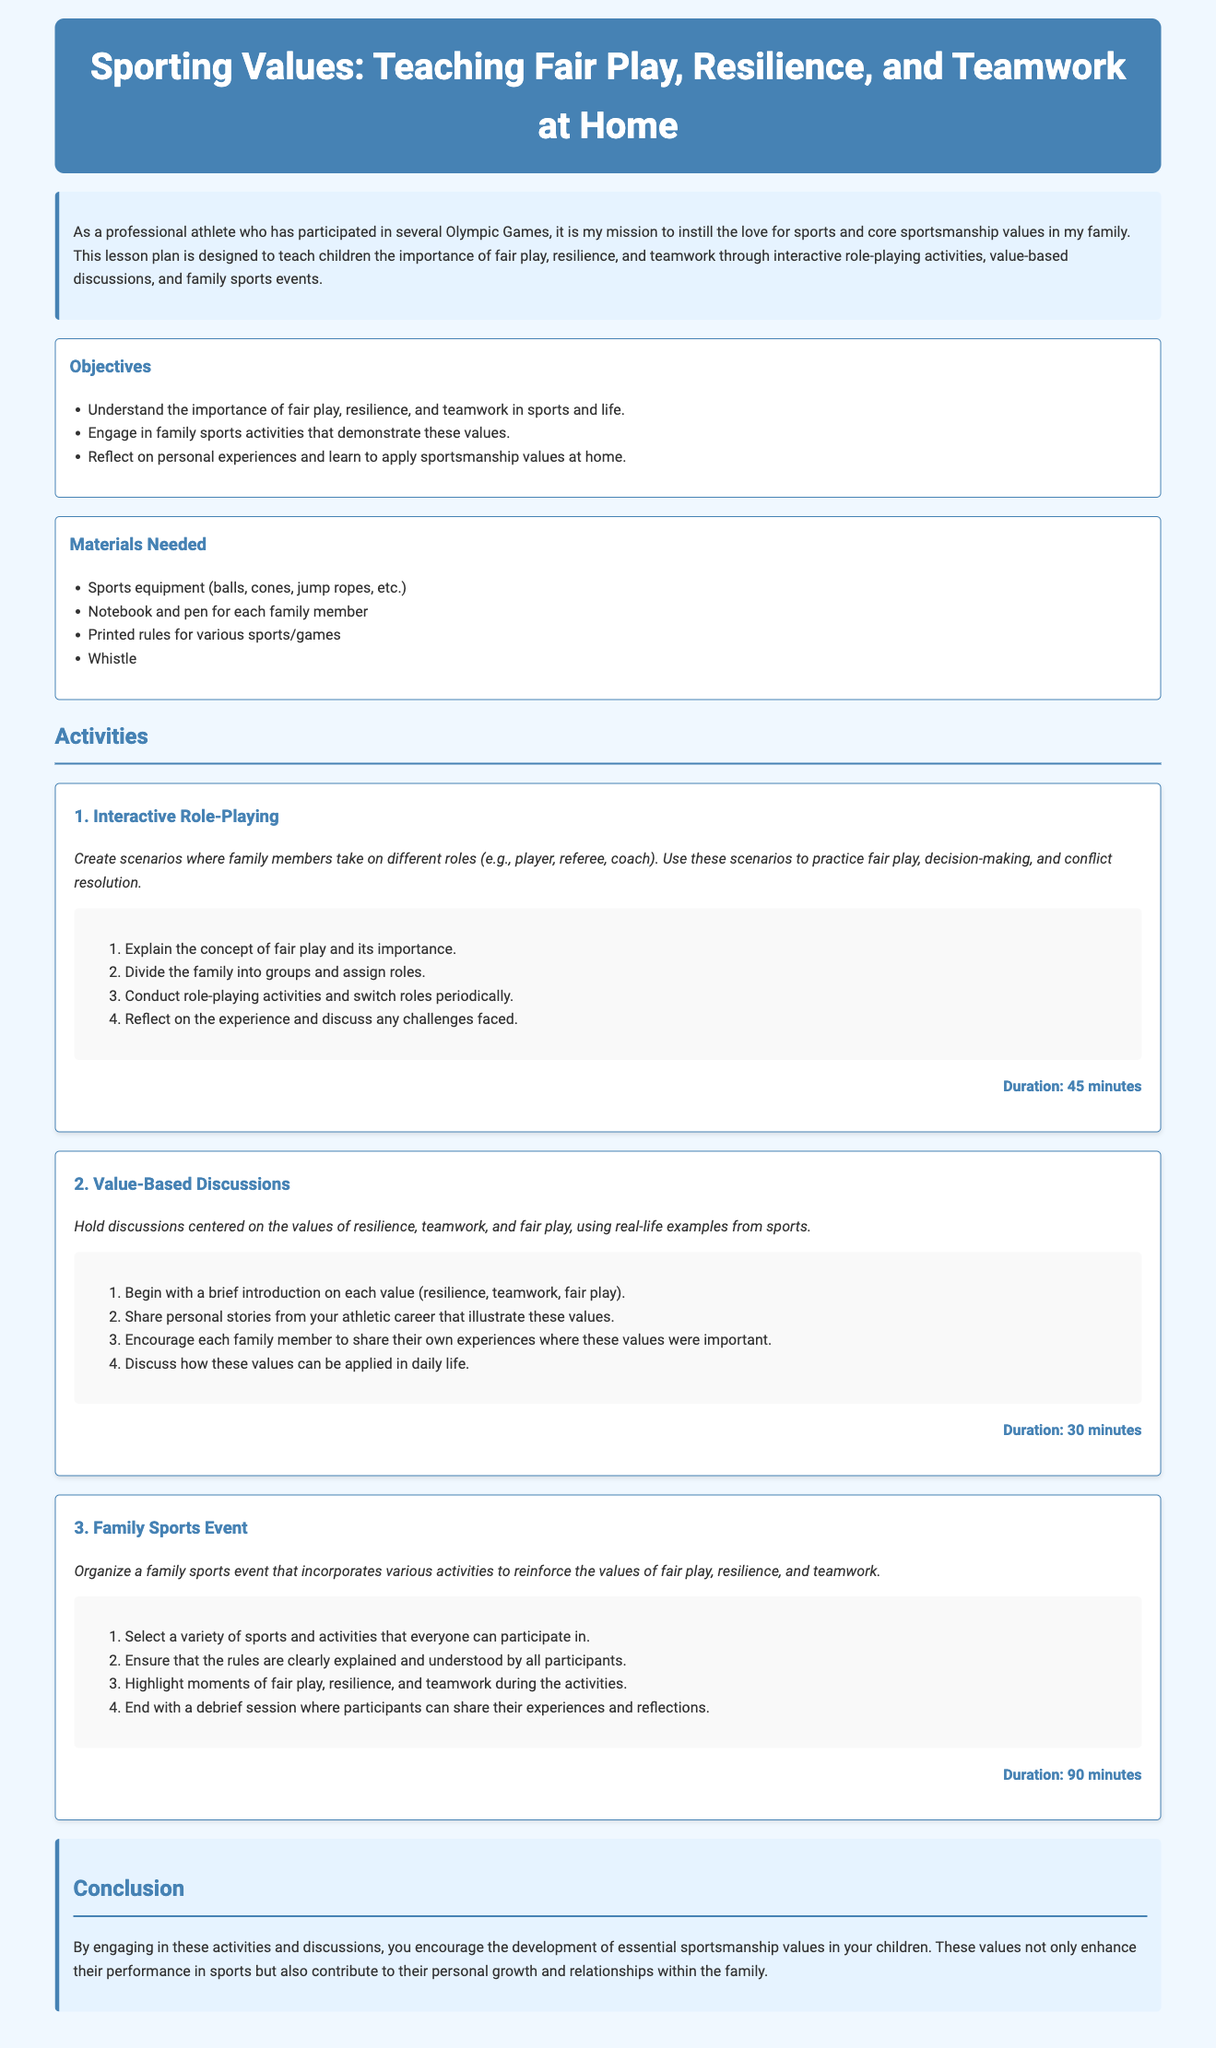What is the main focus of the lesson plan? The main focus of the lesson plan is to teach sporting values such as fair play, resilience, and teamwork at home.
Answer: sporting values How many activities are outlined in the lesson plan? The lesson plan contains three activities.
Answer: 3 What is the duration of the Interactive Role-Playing activity? The Interactive Role-Playing activity has a duration of 45 minutes.
Answer: 45 minutes What materials are needed for the lesson plan? The materials needed include sports equipment, notebook and pen, printed rules, and a whistle.
Answer: sports equipment, notebook and pen, printed rules, whistle What is one of the objectives of this lesson plan? One of the objectives is to engage in family sports activities that demonstrate core values.
Answer: engage in family sports activities What should families discuss during the Value-Based Discussions activity? Families should discuss resilience, teamwork, and fair play using real-life examples from sports.
Answer: resilience, teamwork, fair play What is the purpose of the Family Sports Event? The purpose of the Family Sports Event is to reinforce the values of fair play, resilience, and teamwork.
Answer: reinforce values How are family members encouraged to share their experiences during the lesson? They are encouraged to share personal stories during the value-based discussions.
Answer: value-based discussions What is included in the conclusion of the lesson plan? The conclusion emphasizes the development of essential sportsmanship values in children and their impact on personal growth.
Answer: development of essential sportsmanship values 